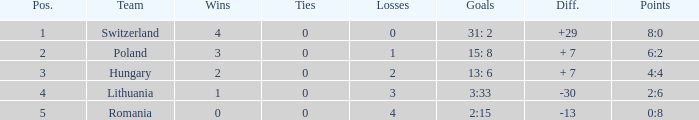When the number of losses was fewer than 4 and there were over 0 ties, what was the highest number of wins achieved? None. Write the full table. {'header': ['Pos.', 'Team', 'Wins', 'Ties', 'Losses', 'Goals', 'Diff.', 'Points'], 'rows': [['1', 'Switzerland', '4', '0', '0', '31: 2', '+29', '8:0'], ['2', 'Poland', '3', '0', '1', '15: 8', '+ 7', '6:2'], ['3', 'Hungary', '2', '0', '2', '13: 6', '+ 7', '4:4'], ['4', 'Lithuania', '1', '0', '3', '3:33', '-30', '2:6'], ['5', 'Romania', '0', '0', '4', '2:15', '-13', '0:8']]} 